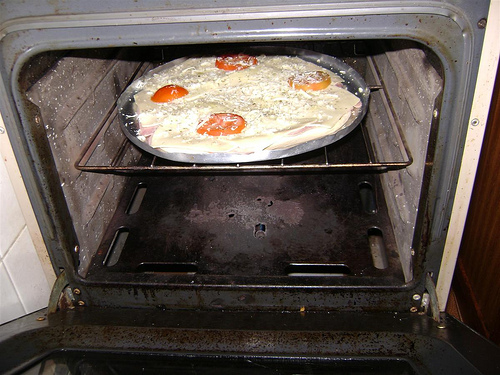<image>When was the oven made? It is unknown when the oven was made. The answer can vary from the 1940s to 1990. When was the oven made? I don't know when the oven was made. 